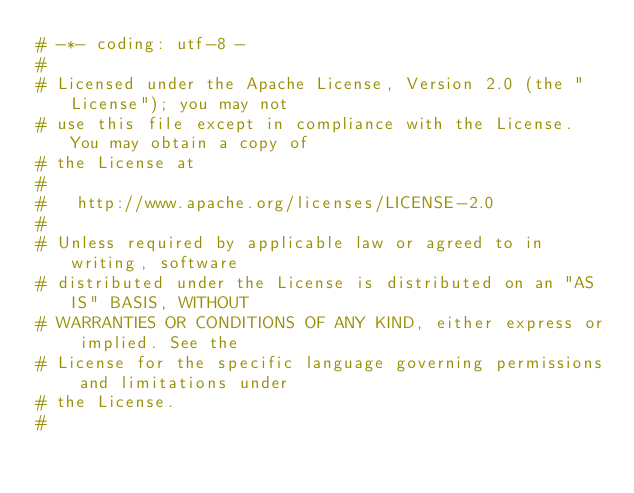Convert code to text. <code><loc_0><loc_0><loc_500><loc_500><_Python_># -*- coding: utf-8 -
#
# Licensed under the Apache License, Version 2.0 (the "License"); you may not
# use this file except in compliance with the License. You may obtain a copy of
# the License at
#
#   http://www.apache.org/licenses/LICENSE-2.0
#
# Unless required by applicable law or agreed to in writing, software
# distributed under the License is distributed on an "AS IS" BASIS, WITHOUT
# WARRANTIES OR CONDITIONS OF ANY KIND, either express or implied. See the
# License for the specific language governing permissions and limitations under
# the License.
#</code> 